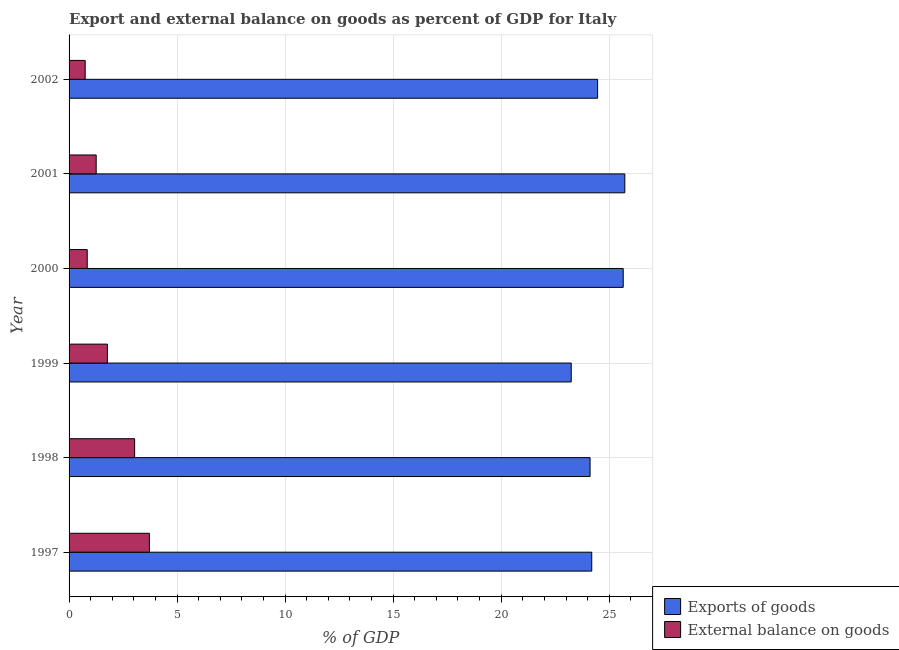How many groups of bars are there?
Provide a short and direct response. 6. How many bars are there on the 6th tick from the bottom?
Give a very brief answer. 2. What is the label of the 3rd group of bars from the top?
Your response must be concise. 2000. What is the export of goods as percentage of gdp in 1999?
Your answer should be compact. 23.24. Across all years, what is the maximum external balance on goods as percentage of gdp?
Your response must be concise. 3.72. Across all years, what is the minimum external balance on goods as percentage of gdp?
Make the answer very short. 0.75. In which year was the export of goods as percentage of gdp maximum?
Make the answer very short. 2001. What is the total export of goods as percentage of gdp in the graph?
Your answer should be very brief. 147.38. What is the difference between the export of goods as percentage of gdp in 2000 and that in 2002?
Provide a short and direct response. 1.19. What is the difference between the export of goods as percentage of gdp in 1998 and the external balance on goods as percentage of gdp in 1997?
Make the answer very short. 20.4. What is the average export of goods as percentage of gdp per year?
Provide a short and direct response. 24.56. In the year 2001, what is the difference between the external balance on goods as percentage of gdp and export of goods as percentage of gdp?
Provide a succinct answer. -24.47. What is the ratio of the external balance on goods as percentage of gdp in 2000 to that in 2001?
Provide a short and direct response. 0.67. What is the difference between the highest and the second highest external balance on goods as percentage of gdp?
Keep it short and to the point. 0.68. What is the difference between the highest and the lowest export of goods as percentage of gdp?
Offer a terse response. 2.48. What does the 1st bar from the top in 2001 represents?
Your response must be concise. External balance on goods. What does the 1st bar from the bottom in 2001 represents?
Keep it short and to the point. Exports of goods. How many years are there in the graph?
Your response must be concise. 6. Are the values on the major ticks of X-axis written in scientific E-notation?
Provide a succinct answer. No. Does the graph contain any zero values?
Offer a very short reply. No. Where does the legend appear in the graph?
Your answer should be compact. Bottom right. How many legend labels are there?
Your answer should be very brief. 2. How are the legend labels stacked?
Your answer should be very brief. Vertical. What is the title of the graph?
Your response must be concise. Export and external balance on goods as percent of GDP for Italy. What is the label or title of the X-axis?
Make the answer very short. % of GDP. What is the label or title of the Y-axis?
Make the answer very short. Year. What is the % of GDP of Exports of goods in 1997?
Offer a very short reply. 24.19. What is the % of GDP of External balance on goods in 1997?
Your response must be concise. 3.72. What is the % of GDP in Exports of goods in 1998?
Your response must be concise. 24.11. What is the % of GDP in External balance on goods in 1998?
Give a very brief answer. 3.03. What is the % of GDP of Exports of goods in 1999?
Offer a very short reply. 23.24. What is the % of GDP in External balance on goods in 1999?
Your response must be concise. 1.78. What is the % of GDP of Exports of goods in 2000?
Keep it short and to the point. 25.65. What is the % of GDP of External balance on goods in 2000?
Ensure brevity in your answer.  0.84. What is the % of GDP of Exports of goods in 2001?
Make the answer very short. 25.72. What is the % of GDP of External balance on goods in 2001?
Your answer should be compact. 1.25. What is the % of GDP of Exports of goods in 2002?
Your response must be concise. 24.46. What is the % of GDP in External balance on goods in 2002?
Provide a short and direct response. 0.75. Across all years, what is the maximum % of GDP of Exports of goods?
Your answer should be very brief. 25.72. Across all years, what is the maximum % of GDP in External balance on goods?
Keep it short and to the point. 3.72. Across all years, what is the minimum % of GDP in Exports of goods?
Offer a terse response. 23.24. Across all years, what is the minimum % of GDP of External balance on goods?
Your response must be concise. 0.75. What is the total % of GDP of Exports of goods in the graph?
Offer a very short reply. 147.38. What is the total % of GDP of External balance on goods in the graph?
Make the answer very short. 11.37. What is the difference between the % of GDP in Exports of goods in 1997 and that in 1998?
Provide a short and direct response. 0.08. What is the difference between the % of GDP of External balance on goods in 1997 and that in 1998?
Your answer should be very brief. 0.68. What is the difference between the % of GDP in Exports of goods in 1997 and that in 1999?
Provide a short and direct response. 0.95. What is the difference between the % of GDP in External balance on goods in 1997 and that in 1999?
Make the answer very short. 1.94. What is the difference between the % of GDP of Exports of goods in 1997 and that in 2000?
Keep it short and to the point. -1.46. What is the difference between the % of GDP in External balance on goods in 1997 and that in 2000?
Offer a very short reply. 2.88. What is the difference between the % of GDP in Exports of goods in 1997 and that in 2001?
Provide a short and direct response. -1.53. What is the difference between the % of GDP in External balance on goods in 1997 and that in 2001?
Give a very brief answer. 2.46. What is the difference between the % of GDP of Exports of goods in 1997 and that in 2002?
Keep it short and to the point. -0.27. What is the difference between the % of GDP in External balance on goods in 1997 and that in 2002?
Your answer should be compact. 2.97. What is the difference between the % of GDP in Exports of goods in 1998 and that in 1999?
Your answer should be compact. 0.87. What is the difference between the % of GDP in External balance on goods in 1998 and that in 1999?
Ensure brevity in your answer.  1.26. What is the difference between the % of GDP of Exports of goods in 1998 and that in 2000?
Your answer should be very brief. -1.53. What is the difference between the % of GDP of External balance on goods in 1998 and that in 2000?
Your answer should be compact. 2.19. What is the difference between the % of GDP in Exports of goods in 1998 and that in 2001?
Offer a very short reply. -1.61. What is the difference between the % of GDP of External balance on goods in 1998 and that in 2001?
Offer a terse response. 1.78. What is the difference between the % of GDP of Exports of goods in 1998 and that in 2002?
Offer a terse response. -0.35. What is the difference between the % of GDP of External balance on goods in 1998 and that in 2002?
Offer a terse response. 2.29. What is the difference between the % of GDP in Exports of goods in 1999 and that in 2000?
Your response must be concise. -2.41. What is the difference between the % of GDP in External balance on goods in 1999 and that in 2000?
Offer a terse response. 0.93. What is the difference between the % of GDP in Exports of goods in 1999 and that in 2001?
Your answer should be compact. -2.48. What is the difference between the % of GDP of External balance on goods in 1999 and that in 2001?
Ensure brevity in your answer.  0.52. What is the difference between the % of GDP in Exports of goods in 1999 and that in 2002?
Your answer should be very brief. -1.22. What is the difference between the % of GDP in External balance on goods in 1999 and that in 2002?
Provide a short and direct response. 1.03. What is the difference between the % of GDP of Exports of goods in 2000 and that in 2001?
Provide a succinct answer. -0.07. What is the difference between the % of GDP of External balance on goods in 2000 and that in 2001?
Give a very brief answer. -0.41. What is the difference between the % of GDP of Exports of goods in 2000 and that in 2002?
Your response must be concise. 1.19. What is the difference between the % of GDP in External balance on goods in 2000 and that in 2002?
Make the answer very short. 0.1. What is the difference between the % of GDP in Exports of goods in 2001 and that in 2002?
Offer a very short reply. 1.26. What is the difference between the % of GDP of External balance on goods in 2001 and that in 2002?
Your answer should be very brief. 0.51. What is the difference between the % of GDP of Exports of goods in 1997 and the % of GDP of External balance on goods in 1998?
Make the answer very short. 21.16. What is the difference between the % of GDP in Exports of goods in 1997 and the % of GDP in External balance on goods in 1999?
Your answer should be compact. 22.42. What is the difference between the % of GDP of Exports of goods in 1997 and the % of GDP of External balance on goods in 2000?
Your answer should be very brief. 23.35. What is the difference between the % of GDP in Exports of goods in 1997 and the % of GDP in External balance on goods in 2001?
Make the answer very short. 22.94. What is the difference between the % of GDP of Exports of goods in 1997 and the % of GDP of External balance on goods in 2002?
Make the answer very short. 23.45. What is the difference between the % of GDP of Exports of goods in 1998 and the % of GDP of External balance on goods in 1999?
Provide a short and direct response. 22.34. What is the difference between the % of GDP of Exports of goods in 1998 and the % of GDP of External balance on goods in 2000?
Your answer should be very brief. 23.27. What is the difference between the % of GDP in Exports of goods in 1998 and the % of GDP in External balance on goods in 2001?
Provide a succinct answer. 22.86. What is the difference between the % of GDP of Exports of goods in 1998 and the % of GDP of External balance on goods in 2002?
Offer a very short reply. 23.37. What is the difference between the % of GDP of Exports of goods in 1999 and the % of GDP of External balance on goods in 2000?
Your answer should be very brief. 22.4. What is the difference between the % of GDP of Exports of goods in 1999 and the % of GDP of External balance on goods in 2001?
Your answer should be very brief. 21.99. What is the difference between the % of GDP of Exports of goods in 1999 and the % of GDP of External balance on goods in 2002?
Your answer should be compact. 22.5. What is the difference between the % of GDP of Exports of goods in 2000 and the % of GDP of External balance on goods in 2001?
Your answer should be very brief. 24.39. What is the difference between the % of GDP in Exports of goods in 2000 and the % of GDP in External balance on goods in 2002?
Ensure brevity in your answer.  24.9. What is the difference between the % of GDP of Exports of goods in 2001 and the % of GDP of External balance on goods in 2002?
Your response must be concise. 24.98. What is the average % of GDP in Exports of goods per year?
Ensure brevity in your answer.  24.56. What is the average % of GDP in External balance on goods per year?
Provide a succinct answer. 1.89. In the year 1997, what is the difference between the % of GDP of Exports of goods and % of GDP of External balance on goods?
Your answer should be very brief. 20.47. In the year 1998, what is the difference between the % of GDP of Exports of goods and % of GDP of External balance on goods?
Your response must be concise. 21.08. In the year 1999, what is the difference between the % of GDP of Exports of goods and % of GDP of External balance on goods?
Your response must be concise. 21.47. In the year 2000, what is the difference between the % of GDP in Exports of goods and % of GDP in External balance on goods?
Your response must be concise. 24.81. In the year 2001, what is the difference between the % of GDP in Exports of goods and % of GDP in External balance on goods?
Keep it short and to the point. 24.47. In the year 2002, what is the difference between the % of GDP of Exports of goods and % of GDP of External balance on goods?
Ensure brevity in your answer.  23.72. What is the ratio of the % of GDP in External balance on goods in 1997 to that in 1998?
Your answer should be very brief. 1.23. What is the ratio of the % of GDP in Exports of goods in 1997 to that in 1999?
Your answer should be very brief. 1.04. What is the ratio of the % of GDP of External balance on goods in 1997 to that in 1999?
Ensure brevity in your answer.  2.09. What is the ratio of the % of GDP in Exports of goods in 1997 to that in 2000?
Give a very brief answer. 0.94. What is the ratio of the % of GDP in External balance on goods in 1997 to that in 2000?
Make the answer very short. 4.42. What is the ratio of the % of GDP of Exports of goods in 1997 to that in 2001?
Make the answer very short. 0.94. What is the ratio of the % of GDP in External balance on goods in 1997 to that in 2001?
Offer a very short reply. 2.96. What is the ratio of the % of GDP of Exports of goods in 1997 to that in 2002?
Ensure brevity in your answer.  0.99. What is the ratio of the % of GDP of External balance on goods in 1997 to that in 2002?
Provide a succinct answer. 4.99. What is the ratio of the % of GDP of Exports of goods in 1998 to that in 1999?
Ensure brevity in your answer.  1.04. What is the ratio of the % of GDP of External balance on goods in 1998 to that in 1999?
Provide a short and direct response. 1.71. What is the ratio of the % of GDP in Exports of goods in 1998 to that in 2000?
Keep it short and to the point. 0.94. What is the ratio of the % of GDP in External balance on goods in 1998 to that in 2000?
Offer a terse response. 3.61. What is the ratio of the % of GDP in External balance on goods in 1998 to that in 2001?
Ensure brevity in your answer.  2.42. What is the ratio of the % of GDP of Exports of goods in 1998 to that in 2002?
Provide a succinct answer. 0.99. What is the ratio of the % of GDP in External balance on goods in 1998 to that in 2002?
Your answer should be compact. 4.07. What is the ratio of the % of GDP in Exports of goods in 1999 to that in 2000?
Offer a very short reply. 0.91. What is the ratio of the % of GDP of External balance on goods in 1999 to that in 2000?
Your response must be concise. 2.11. What is the ratio of the % of GDP in Exports of goods in 1999 to that in 2001?
Your response must be concise. 0.9. What is the ratio of the % of GDP in External balance on goods in 1999 to that in 2001?
Make the answer very short. 1.41. What is the ratio of the % of GDP of Exports of goods in 1999 to that in 2002?
Ensure brevity in your answer.  0.95. What is the ratio of the % of GDP in External balance on goods in 1999 to that in 2002?
Provide a succinct answer. 2.38. What is the ratio of the % of GDP in External balance on goods in 2000 to that in 2001?
Make the answer very short. 0.67. What is the ratio of the % of GDP of Exports of goods in 2000 to that in 2002?
Your answer should be very brief. 1.05. What is the ratio of the % of GDP in External balance on goods in 2000 to that in 2002?
Your answer should be compact. 1.13. What is the ratio of the % of GDP of Exports of goods in 2001 to that in 2002?
Offer a very short reply. 1.05. What is the ratio of the % of GDP in External balance on goods in 2001 to that in 2002?
Ensure brevity in your answer.  1.68. What is the difference between the highest and the second highest % of GDP of Exports of goods?
Your answer should be very brief. 0.07. What is the difference between the highest and the second highest % of GDP of External balance on goods?
Ensure brevity in your answer.  0.68. What is the difference between the highest and the lowest % of GDP of Exports of goods?
Your answer should be compact. 2.48. What is the difference between the highest and the lowest % of GDP in External balance on goods?
Make the answer very short. 2.97. 